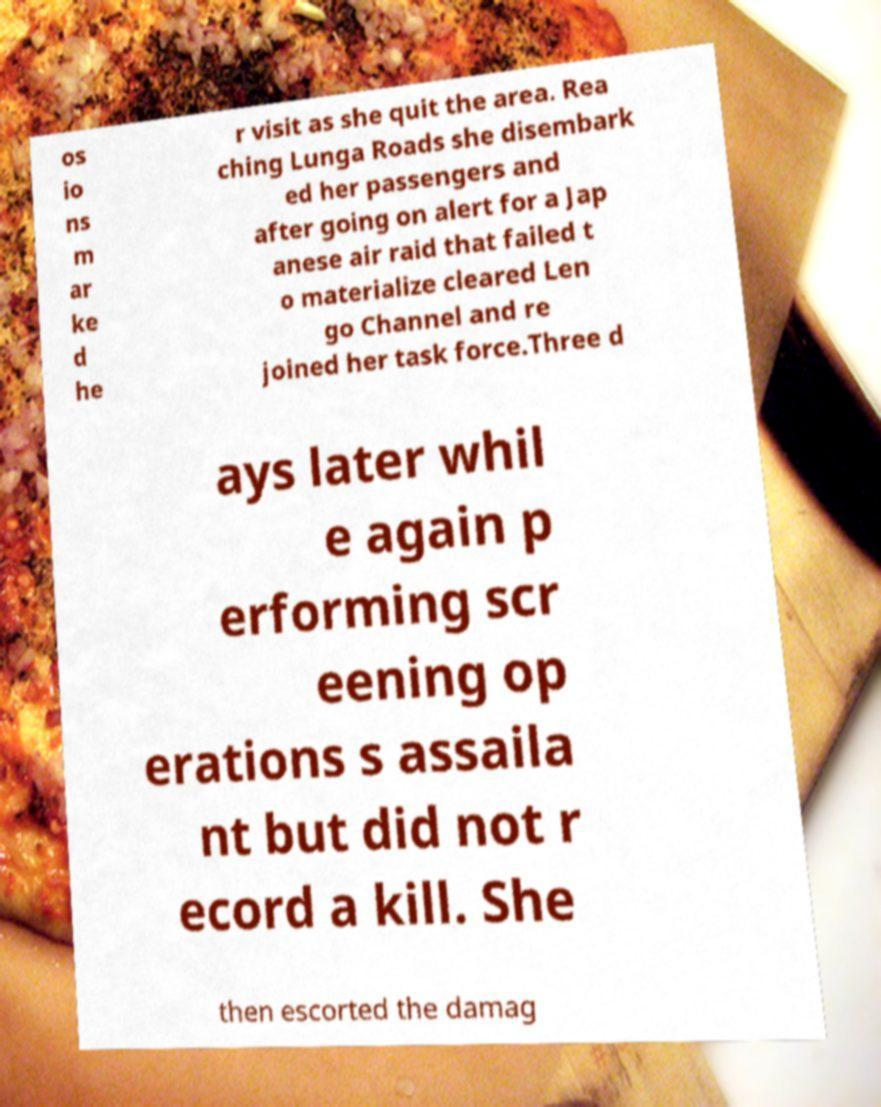Please identify and transcribe the text found in this image. os io ns m ar ke d he r visit as she quit the area. Rea ching Lunga Roads she disembark ed her passengers and after going on alert for a Jap anese air raid that failed t o materialize cleared Len go Channel and re joined her task force.Three d ays later whil e again p erforming scr eening op erations s assaila nt but did not r ecord a kill. She then escorted the damag 